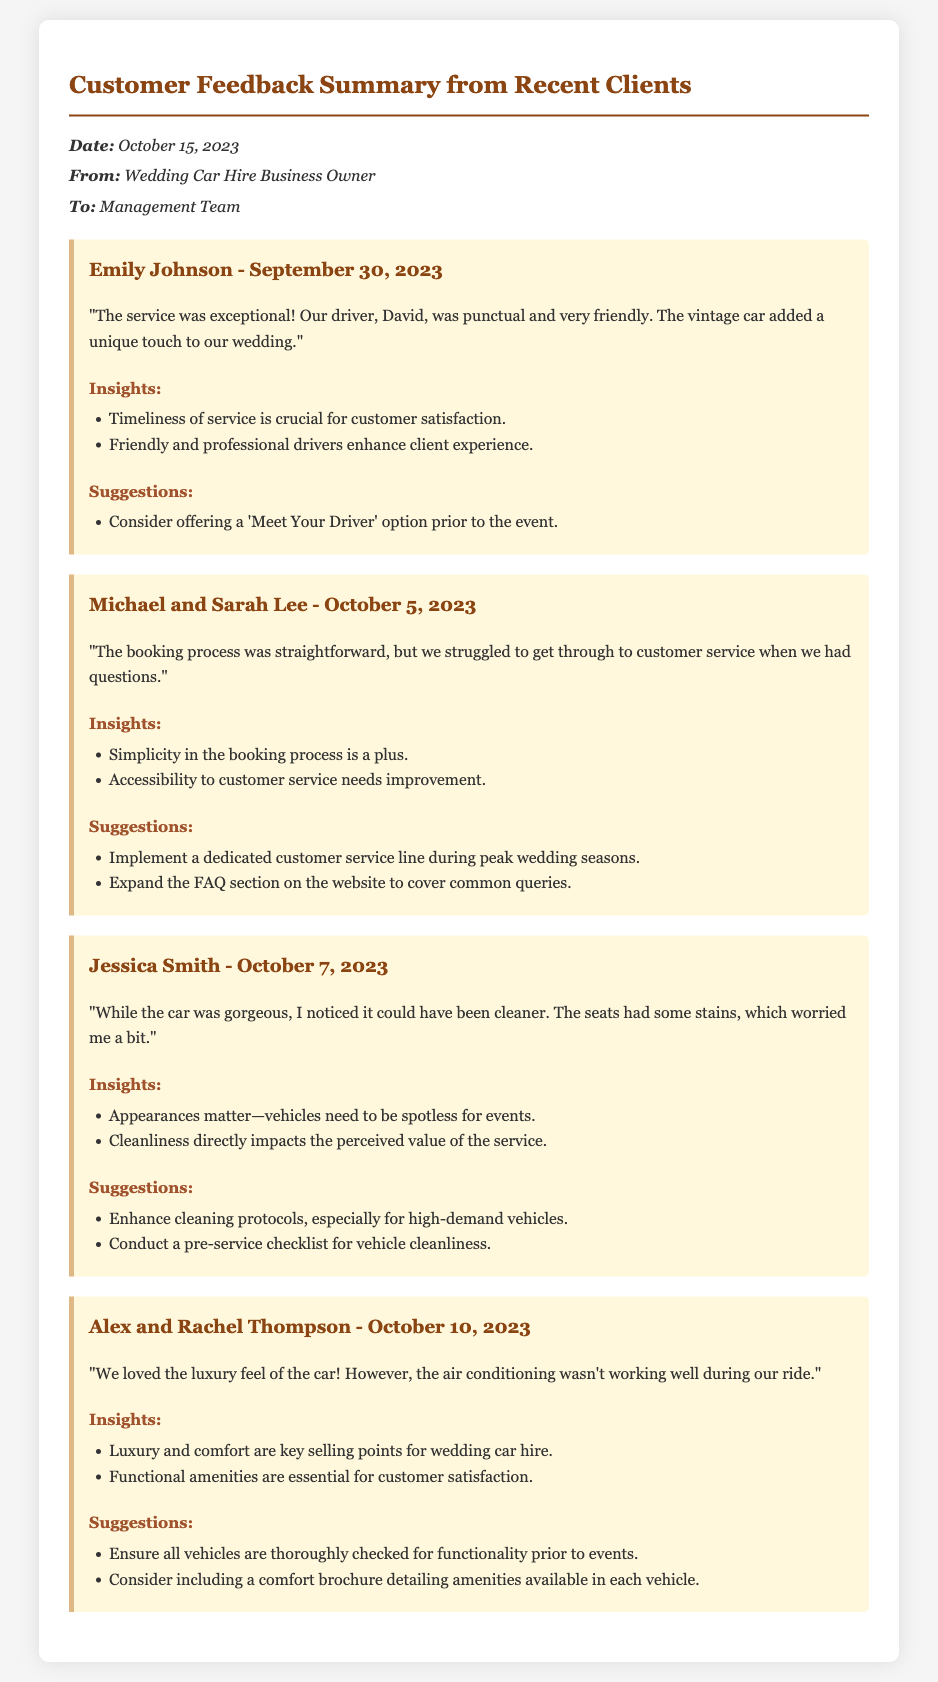what is the date of the memo? The date of the memo is stated in the header section.
Answer: October 15, 2023 who is the driver mentioned in Emily Johnson's feedback? Emily Johnson's feedback refers to a driver by name, which is highlighted in her comment.
Answer: David what was the main issue raised by Michael and Sarah Lee? The document mentions the specific concern that Michael and Sarah Lee experienced with customer service.
Answer: Difficulty reaching customer service which client mentioned cleanliness issues with the vehicle? The specific client who raised concerns about cleanliness is identified in the document.
Answer: Jessica Smith what suggestion was made to improve customer service accessibility? A suggestion is provided in the feedback section regarding improving customer service during busy times.
Answer: Implement a dedicated customer service line during peak wedding seasons which vehicle feature was not functioning properly according to Alex and Rachel Thompson? The feedback indicates a specific feature that was problematic during their ride, addressing concerns about comfort.
Answer: Air conditioning how many feedback items are included in the summary? The number of feedback items is counted from the sections contained within the memo.
Answer: Four what aspect of the booking process was praised by Michael and Sarah Lee? The feedback explicitly praises a certain quality of the booking experience mentioned by the clients.
Answer: Simplicity which insight relates to the appearance of the vehicles? Insights related to vehicle cleanliness and its importance are highlighted in Jessica Smith's feedback.
Answer: Appearances matter—vehicles need to be spotless for events 